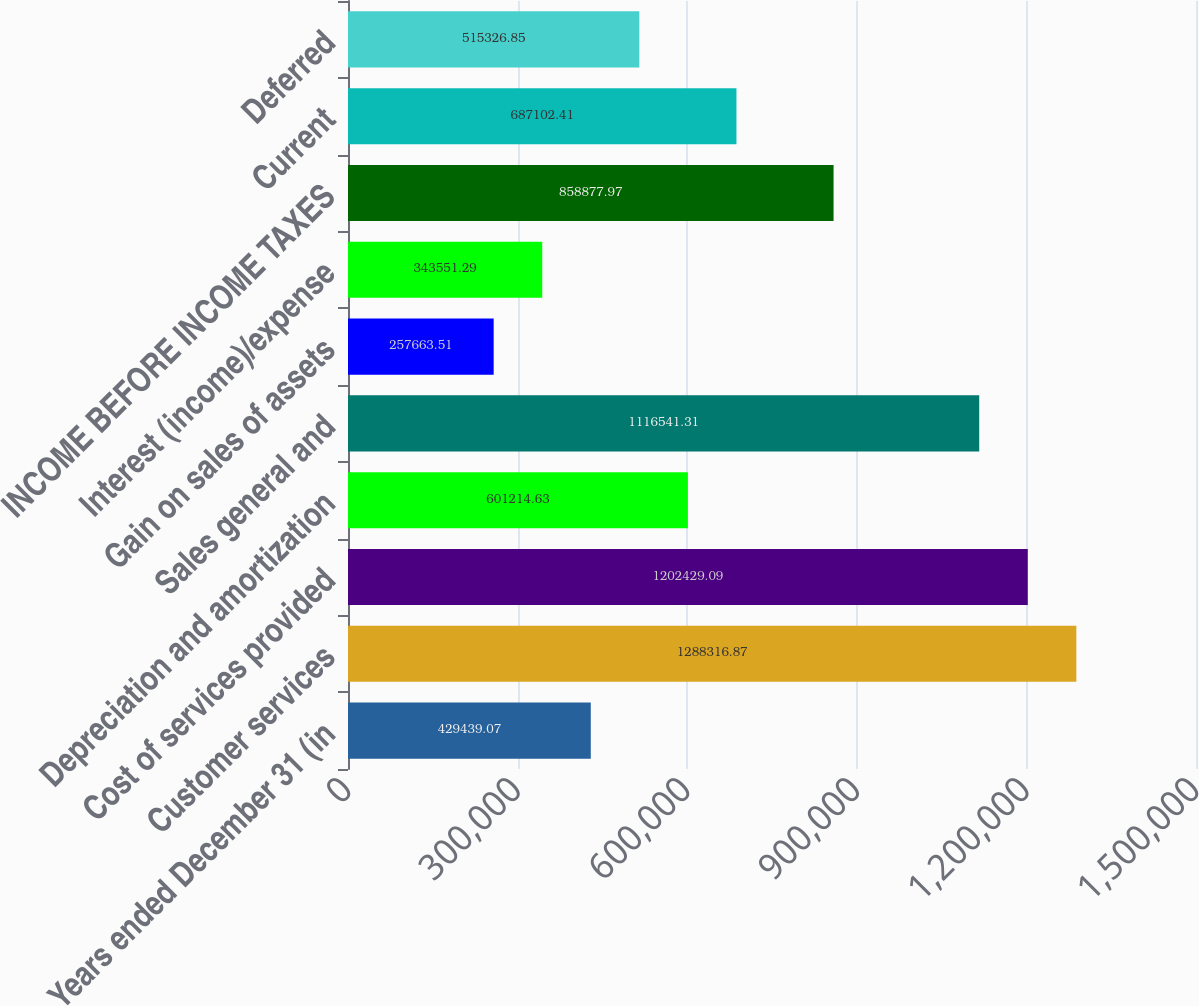Convert chart. <chart><loc_0><loc_0><loc_500><loc_500><bar_chart><fcel>Years ended December 31 (in<fcel>Customer services<fcel>Cost of services provided<fcel>Depreciation and amortization<fcel>Sales general and<fcel>Gain on sales of assets<fcel>Interest (income)/expense<fcel>INCOME BEFORE INCOME TAXES<fcel>Current<fcel>Deferred<nl><fcel>429439<fcel>1.28832e+06<fcel>1.20243e+06<fcel>601215<fcel>1.11654e+06<fcel>257664<fcel>343551<fcel>858878<fcel>687102<fcel>515327<nl></chart> 